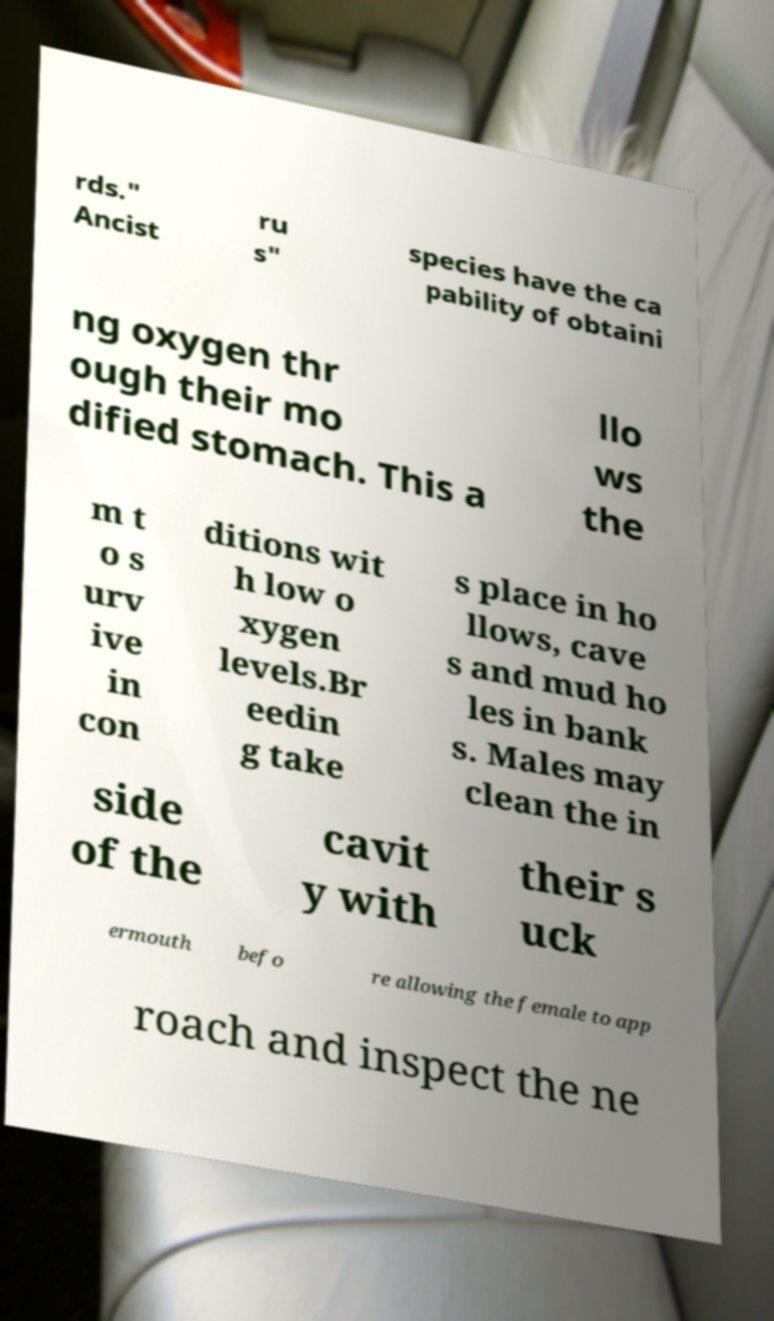Can you accurately transcribe the text from the provided image for me? rds." Ancist ru s" species have the ca pability of obtaini ng oxygen thr ough their mo dified stomach. This a llo ws the m t o s urv ive in con ditions wit h low o xygen levels.Br eedin g take s place in ho llows, cave s and mud ho les in bank s. Males may clean the in side of the cavit y with their s uck ermouth befo re allowing the female to app roach and inspect the ne 